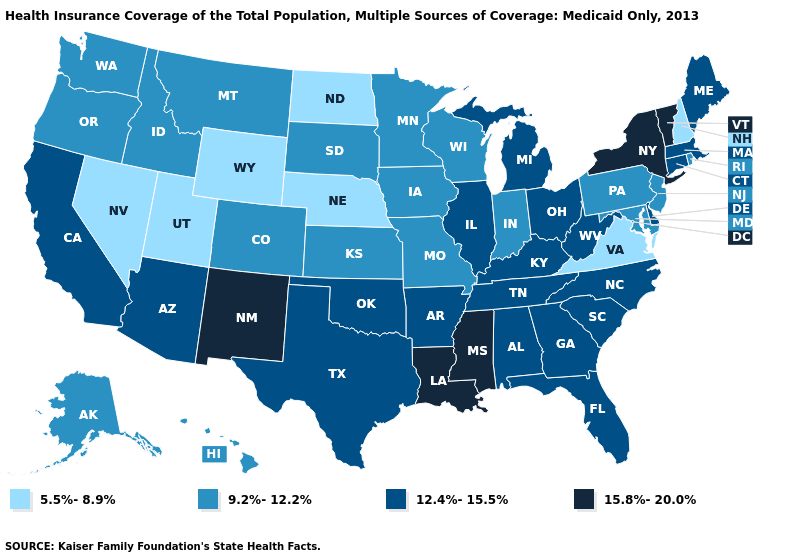What is the value of Iowa?
Short answer required. 9.2%-12.2%. Name the states that have a value in the range 5.5%-8.9%?
Answer briefly. Nebraska, Nevada, New Hampshire, North Dakota, Utah, Virginia, Wyoming. Does the first symbol in the legend represent the smallest category?
Give a very brief answer. Yes. What is the highest value in states that border Idaho?
Be succinct. 9.2%-12.2%. Which states have the highest value in the USA?
Concise answer only. Louisiana, Mississippi, New Mexico, New York, Vermont. Does New Hampshire have the highest value in the Northeast?
Concise answer only. No. Among the states that border Kentucky , does Illinois have the highest value?
Quick response, please. Yes. Name the states that have a value in the range 12.4%-15.5%?
Quick response, please. Alabama, Arizona, Arkansas, California, Connecticut, Delaware, Florida, Georgia, Illinois, Kentucky, Maine, Massachusetts, Michigan, North Carolina, Ohio, Oklahoma, South Carolina, Tennessee, Texas, West Virginia. What is the value of New York?
Answer briefly. 15.8%-20.0%. What is the highest value in the USA?
Keep it brief. 15.8%-20.0%. Among the states that border Pennsylvania , which have the lowest value?
Answer briefly. Maryland, New Jersey. What is the highest value in states that border Connecticut?
Answer briefly. 15.8%-20.0%. Name the states that have a value in the range 9.2%-12.2%?
Be succinct. Alaska, Colorado, Hawaii, Idaho, Indiana, Iowa, Kansas, Maryland, Minnesota, Missouri, Montana, New Jersey, Oregon, Pennsylvania, Rhode Island, South Dakota, Washington, Wisconsin. 